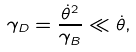Convert formula to latex. <formula><loc_0><loc_0><loc_500><loc_500>\gamma _ { D } = \frac { \dot { \theta } ^ { 2 } } { \gamma _ { B } } \ll \dot { \theta } ,</formula> 